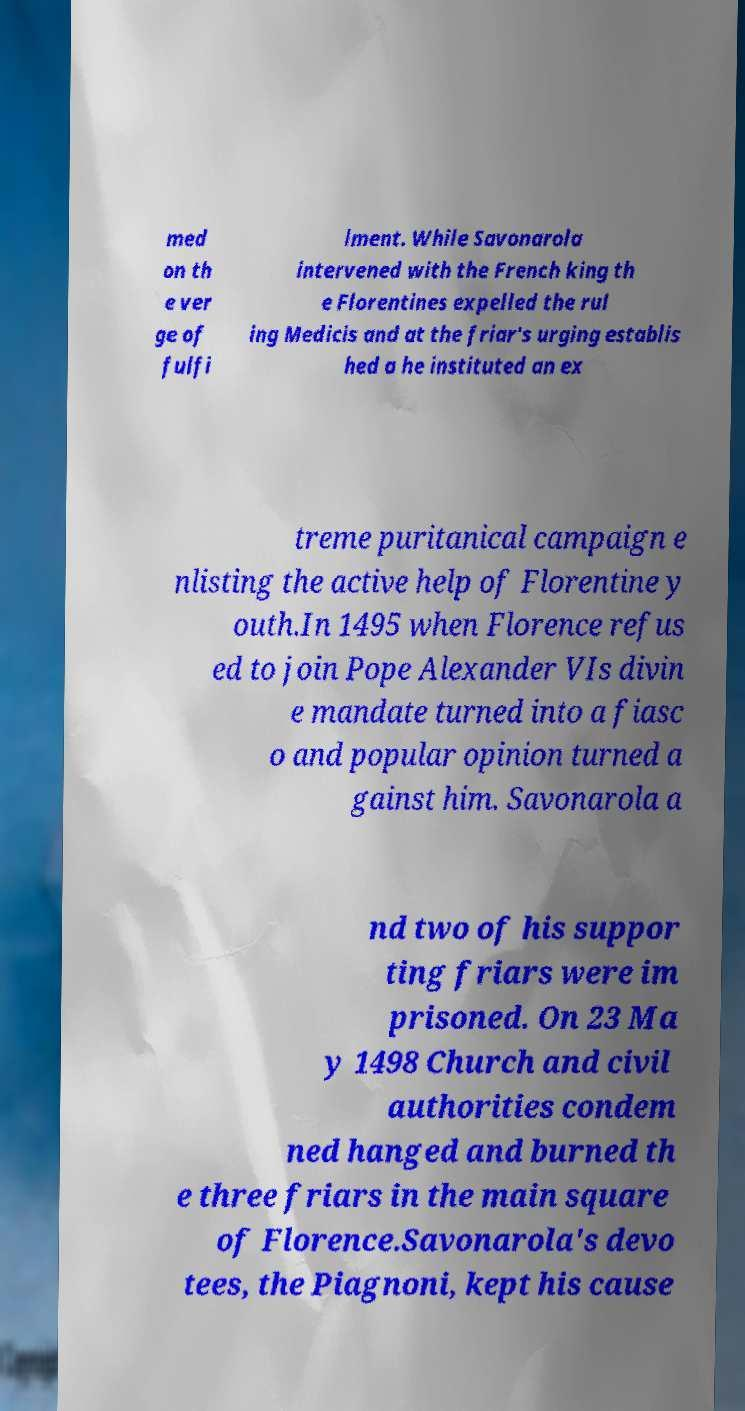For documentation purposes, I need the text within this image transcribed. Could you provide that? med on th e ver ge of fulfi lment. While Savonarola intervened with the French king th e Florentines expelled the rul ing Medicis and at the friar's urging establis hed a he instituted an ex treme puritanical campaign e nlisting the active help of Florentine y outh.In 1495 when Florence refus ed to join Pope Alexander VIs divin e mandate turned into a fiasc o and popular opinion turned a gainst him. Savonarola a nd two of his suppor ting friars were im prisoned. On 23 Ma y 1498 Church and civil authorities condem ned hanged and burned th e three friars in the main square of Florence.Savonarola's devo tees, the Piagnoni, kept his cause 